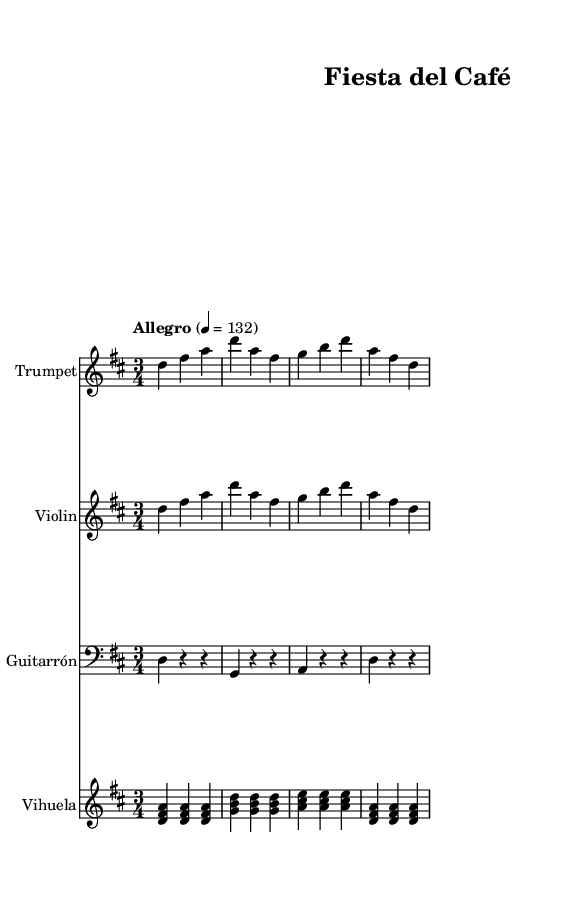What is the key signature of this music? The key signature is D major, which has two sharps (F# and C#). This can be identified in the opening section of the sheet music, where the key signature symbol indicates the tonal center.
Answer: D major What is the time signature of this music? The time signature is 3/4, as indicated at the beginning of the score. This signifies that each measure contains three beats, with a quarter note receiving one beat.
Answer: 3/4 What is the tempo marking of this music? The tempo marking is "Allegro," which means fast. The specific speed is indicated as the beats per minute (BPM), which in this score is set to 132 BPM. This can be found in the tempo marking section of the sheet music.
Answer: Allegro How many measures are in the trumpet part? The trumpet part has four measures, which can be counted directly from the notes presented in the staff. Each group of notes separated by vertical lines represents a measure, and counting them gives four.
Answer: Four What instruments are included in this piece? The piece includes trumpet, violin, guitarrón, and vihuela as indicated by the staff names at the beginning of each section. Each instrument has its own designated staff where the corresponding music is written.
Answer: Trumpet, violin, guitarrón, vihuela What is the lyric phrase sung by the trumpet? The lyric phrase is "¡Bien -- ve -- ni -- dos a -- mi -- gos, al ca -- fé con sa -- bor!" These phrases are written directly beneath the trumpet part and can be seen easily on the sheet music.
Answer: ¡Bienvenidos a mígos, al café con sabor! 